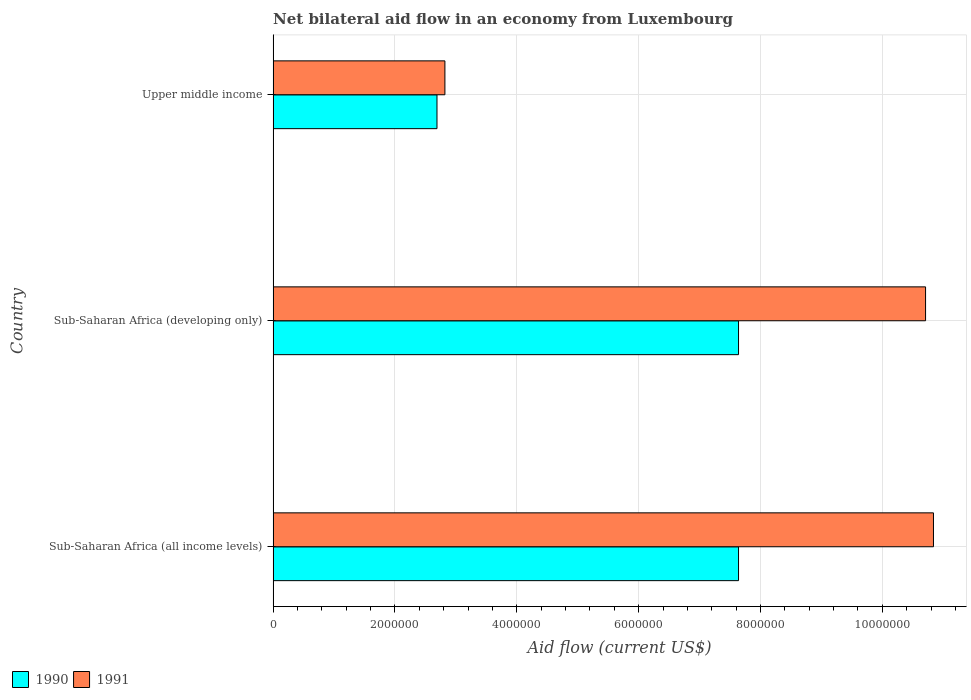How many different coloured bars are there?
Keep it short and to the point. 2. Are the number of bars per tick equal to the number of legend labels?
Keep it short and to the point. Yes. How many bars are there on the 1st tick from the bottom?
Make the answer very short. 2. What is the label of the 3rd group of bars from the top?
Give a very brief answer. Sub-Saharan Africa (all income levels). What is the net bilateral aid flow in 1990 in Sub-Saharan Africa (developing only)?
Your answer should be very brief. 7.64e+06. Across all countries, what is the maximum net bilateral aid flow in 1991?
Provide a succinct answer. 1.08e+07. Across all countries, what is the minimum net bilateral aid flow in 1990?
Keep it short and to the point. 2.69e+06. In which country was the net bilateral aid flow in 1991 maximum?
Offer a very short reply. Sub-Saharan Africa (all income levels). In which country was the net bilateral aid flow in 1991 minimum?
Make the answer very short. Upper middle income. What is the total net bilateral aid flow in 1991 in the graph?
Your answer should be very brief. 2.44e+07. What is the difference between the net bilateral aid flow in 1990 in Sub-Saharan Africa (all income levels) and the net bilateral aid flow in 1991 in Sub-Saharan Africa (developing only)?
Your answer should be very brief. -3.07e+06. What is the average net bilateral aid flow in 1990 per country?
Give a very brief answer. 5.99e+06. What is the difference between the net bilateral aid flow in 1991 and net bilateral aid flow in 1990 in Sub-Saharan Africa (all income levels)?
Give a very brief answer. 3.20e+06. What is the ratio of the net bilateral aid flow in 1991 in Sub-Saharan Africa (all income levels) to that in Sub-Saharan Africa (developing only)?
Give a very brief answer. 1.01. Is the difference between the net bilateral aid flow in 1991 in Sub-Saharan Africa (all income levels) and Upper middle income greater than the difference between the net bilateral aid flow in 1990 in Sub-Saharan Africa (all income levels) and Upper middle income?
Your answer should be very brief. Yes. What is the difference between the highest and the lowest net bilateral aid flow in 1991?
Offer a terse response. 8.02e+06. How many countries are there in the graph?
Your answer should be compact. 3. Are the values on the major ticks of X-axis written in scientific E-notation?
Your answer should be compact. No. Does the graph contain any zero values?
Your answer should be very brief. No. Does the graph contain grids?
Provide a short and direct response. Yes. How are the legend labels stacked?
Ensure brevity in your answer.  Horizontal. What is the title of the graph?
Make the answer very short. Net bilateral aid flow in an economy from Luxembourg. What is the label or title of the X-axis?
Offer a terse response. Aid flow (current US$). What is the Aid flow (current US$) of 1990 in Sub-Saharan Africa (all income levels)?
Give a very brief answer. 7.64e+06. What is the Aid flow (current US$) in 1991 in Sub-Saharan Africa (all income levels)?
Offer a terse response. 1.08e+07. What is the Aid flow (current US$) in 1990 in Sub-Saharan Africa (developing only)?
Keep it short and to the point. 7.64e+06. What is the Aid flow (current US$) of 1991 in Sub-Saharan Africa (developing only)?
Keep it short and to the point. 1.07e+07. What is the Aid flow (current US$) in 1990 in Upper middle income?
Provide a succinct answer. 2.69e+06. What is the Aid flow (current US$) of 1991 in Upper middle income?
Make the answer very short. 2.82e+06. Across all countries, what is the maximum Aid flow (current US$) of 1990?
Your answer should be very brief. 7.64e+06. Across all countries, what is the maximum Aid flow (current US$) of 1991?
Give a very brief answer. 1.08e+07. Across all countries, what is the minimum Aid flow (current US$) in 1990?
Provide a short and direct response. 2.69e+06. Across all countries, what is the minimum Aid flow (current US$) of 1991?
Your response must be concise. 2.82e+06. What is the total Aid flow (current US$) in 1990 in the graph?
Provide a short and direct response. 1.80e+07. What is the total Aid flow (current US$) in 1991 in the graph?
Offer a terse response. 2.44e+07. What is the difference between the Aid flow (current US$) in 1990 in Sub-Saharan Africa (all income levels) and that in Sub-Saharan Africa (developing only)?
Make the answer very short. 0. What is the difference between the Aid flow (current US$) of 1991 in Sub-Saharan Africa (all income levels) and that in Sub-Saharan Africa (developing only)?
Keep it short and to the point. 1.30e+05. What is the difference between the Aid flow (current US$) of 1990 in Sub-Saharan Africa (all income levels) and that in Upper middle income?
Offer a very short reply. 4.95e+06. What is the difference between the Aid flow (current US$) of 1991 in Sub-Saharan Africa (all income levels) and that in Upper middle income?
Your response must be concise. 8.02e+06. What is the difference between the Aid flow (current US$) of 1990 in Sub-Saharan Africa (developing only) and that in Upper middle income?
Offer a terse response. 4.95e+06. What is the difference between the Aid flow (current US$) of 1991 in Sub-Saharan Africa (developing only) and that in Upper middle income?
Your response must be concise. 7.89e+06. What is the difference between the Aid flow (current US$) of 1990 in Sub-Saharan Africa (all income levels) and the Aid flow (current US$) of 1991 in Sub-Saharan Africa (developing only)?
Offer a terse response. -3.07e+06. What is the difference between the Aid flow (current US$) of 1990 in Sub-Saharan Africa (all income levels) and the Aid flow (current US$) of 1991 in Upper middle income?
Keep it short and to the point. 4.82e+06. What is the difference between the Aid flow (current US$) in 1990 in Sub-Saharan Africa (developing only) and the Aid flow (current US$) in 1991 in Upper middle income?
Make the answer very short. 4.82e+06. What is the average Aid flow (current US$) of 1990 per country?
Ensure brevity in your answer.  5.99e+06. What is the average Aid flow (current US$) of 1991 per country?
Your answer should be compact. 8.12e+06. What is the difference between the Aid flow (current US$) of 1990 and Aid flow (current US$) of 1991 in Sub-Saharan Africa (all income levels)?
Your answer should be compact. -3.20e+06. What is the difference between the Aid flow (current US$) of 1990 and Aid flow (current US$) of 1991 in Sub-Saharan Africa (developing only)?
Your answer should be very brief. -3.07e+06. What is the difference between the Aid flow (current US$) in 1990 and Aid flow (current US$) in 1991 in Upper middle income?
Your answer should be compact. -1.30e+05. What is the ratio of the Aid flow (current US$) in 1991 in Sub-Saharan Africa (all income levels) to that in Sub-Saharan Africa (developing only)?
Your response must be concise. 1.01. What is the ratio of the Aid flow (current US$) in 1990 in Sub-Saharan Africa (all income levels) to that in Upper middle income?
Make the answer very short. 2.84. What is the ratio of the Aid flow (current US$) of 1991 in Sub-Saharan Africa (all income levels) to that in Upper middle income?
Make the answer very short. 3.84. What is the ratio of the Aid flow (current US$) in 1990 in Sub-Saharan Africa (developing only) to that in Upper middle income?
Your answer should be very brief. 2.84. What is the ratio of the Aid flow (current US$) of 1991 in Sub-Saharan Africa (developing only) to that in Upper middle income?
Offer a terse response. 3.8. What is the difference between the highest and the second highest Aid flow (current US$) in 1990?
Offer a very short reply. 0. What is the difference between the highest and the second highest Aid flow (current US$) in 1991?
Give a very brief answer. 1.30e+05. What is the difference between the highest and the lowest Aid flow (current US$) of 1990?
Offer a very short reply. 4.95e+06. What is the difference between the highest and the lowest Aid flow (current US$) in 1991?
Your answer should be compact. 8.02e+06. 